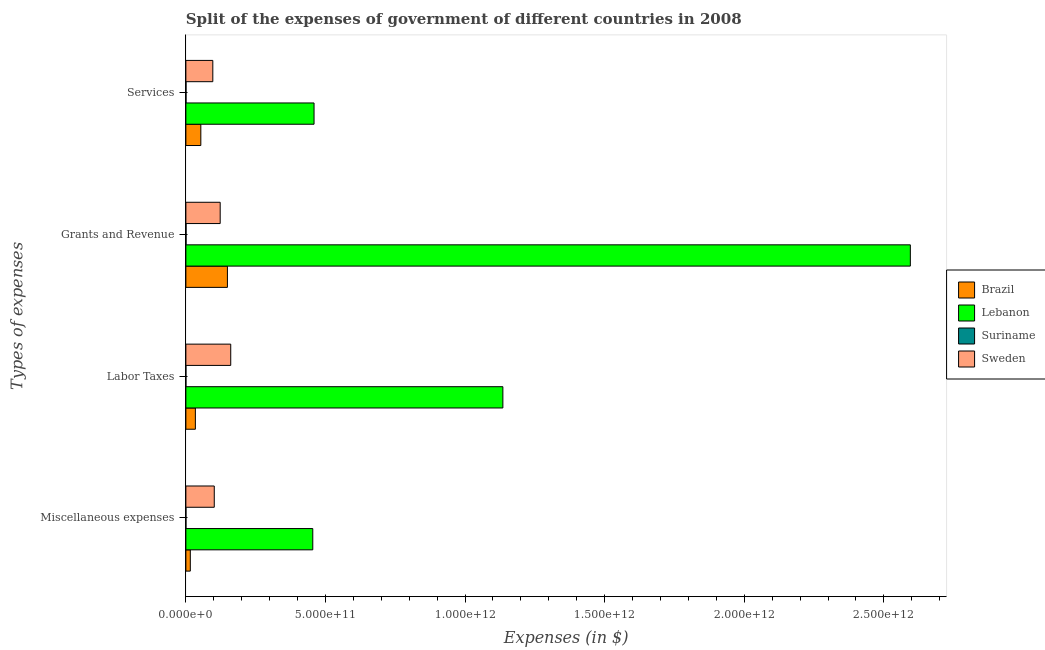What is the label of the 4th group of bars from the top?
Offer a very short reply. Miscellaneous expenses. What is the amount spent on miscellaneous expenses in Lebanon?
Your answer should be compact. 4.55e+11. Across all countries, what is the maximum amount spent on labor taxes?
Provide a short and direct response. 1.14e+12. Across all countries, what is the minimum amount spent on miscellaneous expenses?
Provide a short and direct response. 2.44e+08. In which country was the amount spent on services maximum?
Keep it short and to the point. Lebanon. In which country was the amount spent on miscellaneous expenses minimum?
Provide a short and direct response. Suriname. What is the total amount spent on miscellaneous expenses in the graph?
Offer a very short reply. 5.72e+11. What is the difference between the amount spent on grants and revenue in Suriname and that in Lebanon?
Keep it short and to the point. -2.59e+12. What is the difference between the amount spent on miscellaneous expenses in Brazil and the amount spent on labor taxes in Suriname?
Your response must be concise. 1.58e+1. What is the average amount spent on grants and revenue per country?
Provide a succinct answer. 7.17e+11. What is the difference between the amount spent on grants and revenue and amount spent on services in Lebanon?
Your response must be concise. 2.14e+12. In how many countries, is the amount spent on grants and revenue greater than 900000000000 $?
Offer a terse response. 1. What is the ratio of the amount spent on labor taxes in Sweden to that in Suriname?
Your response must be concise. 1904.67. Is the amount spent on labor taxes in Sweden less than that in Suriname?
Make the answer very short. No. What is the difference between the highest and the second highest amount spent on labor taxes?
Offer a very short reply. 9.75e+11. What is the difference between the highest and the lowest amount spent on services?
Your answer should be compact. 4.59e+11. Is the sum of the amount spent on labor taxes in Brazil and Suriname greater than the maximum amount spent on grants and revenue across all countries?
Give a very brief answer. No. Is it the case that in every country, the sum of the amount spent on miscellaneous expenses and amount spent on labor taxes is greater than the amount spent on grants and revenue?
Make the answer very short. No. How many bars are there?
Provide a short and direct response. 16. Are all the bars in the graph horizontal?
Ensure brevity in your answer.  Yes. How many countries are there in the graph?
Your answer should be very brief. 4. What is the difference between two consecutive major ticks on the X-axis?
Give a very brief answer. 5.00e+11. How many legend labels are there?
Your answer should be compact. 4. How are the legend labels stacked?
Ensure brevity in your answer.  Vertical. What is the title of the graph?
Give a very brief answer. Split of the expenses of government of different countries in 2008. What is the label or title of the X-axis?
Your answer should be compact. Expenses (in $). What is the label or title of the Y-axis?
Offer a very short reply. Types of expenses. What is the Expenses (in $) of Brazil in Miscellaneous expenses?
Give a very brief answer. 1.59e+1. What is the Expenses (in $) of Lebanon in Miscellaneous expenses?
Provide a short and direct response. 4.55e+11. What is the Expenses (in $) in Suriname in Miscellaneous expenses?
Your answer should be very brief. 2.44e+08. What is the Expenses (in $) in Sweden in Miscellaneous expenses?
Your answer should be compact. 1.02e+11. What is the Expenses (in $) in Brazil in Labor Taxes?
Provide a succinct answer. 3.40e+1. What is the Expenses (in $) of Lebanon in Labor Taxes?
Your answer should be compact. 1.14e+12. What is the Expenses (in $) of Suriname in Labor Taxes?
Offer a very short reply. 8.44e+07. What is the Expenses (in $) in Sweden in Labor Taxes?
Provide a succinct answer. 1.61e+11. What is the Expenses (in $) of Brazil in Grants and Revenue?
Ensure brevity in your answer.  1.49e+11. What is the Expenses (in $) in Lebanon in Grants and Revenue?
Offer a very short reply. 2.59e+12. What is the Expenses (in $) of Suriname in Grants and Revenue?
Give a very brief answer. 6.72e+08. What is the Expenses (in $) in Sweden in Grants and Revenue?
Your answer should be compact. 1.23e+11. What is the Expenses (in $) of Brazil in Services?
Your answer should be very brief. 5.36e+1. What is the Expenses (in $) of Lebanon in Services?
Provide a short and direct response. 4.59e+11. What is the Expenses (in $) in Suriname in Services?
Offer a terse response. 4.88e+08. What is the Expenses (in $) of Sweden in Services?
Provide a short and direct response. 9.65e+1. Across all Types of expenses, what is the maximum Expenses (in $) of Brazil?
Give a very brief answer. 1.49e+11. Across all Types of expenses, what is the maximum Expenses (in $) of Lebanon?
Ensure brevity in your answer.  2.59e+12. Across all Types of expenses, what is the maximum Expenses (in $) of Suriname?
Make the answer very short. 6.72e+08. Across all Types of expenses, what is the maximum Expenses (in $) in Sweden?
Ensure brevity in your answer.  1.61e+11. Across all Types of expenses, what is the minimum Expenses (in $) of Brazil?
Your answer should be compact. 1.59e+1. Across all Types of expenses, what is the minimum Expenses (in $) in Lebanon?
Ensure brevity in your answer.  4.55e+11. Across all Types of expenses, what is the minimum Expenses (in $) in Suriname?
Provide a short and direct response. 8.44e+07. Across all Types of expenses, what is the minimum Expenses (in $) of Sweden?
Make the answer very short. 9.65e+1. What is the total Expenses (in $) in Brazil in the graph?
Ensure brevity in your answer.  2.52e+11. What is the total Expenses (in $) in Lebanon in the graph?
Keep it short and to the point. 4.64e+12. What is the total Expenses (in $) of Suriname in the graph?
Make the answer very short. 1.49e+09. What is the total Expenses (in $) in Sweden in the graph?
Provide a succinct answer. 4.82e+11. What is the difference between the Expenses (in $) in Brazil in Miscellaneous expenses and that in Labor Taxes?
Your answer should be compact. -1.81e+1. What is the difference between the Expenses (in $) in Lebanon in Miscellaneous expenses and that in Labor Taxes?
Make the answer very short. -6.81e+11. What is the difference between the Expenses (in $) of Suriname in Miscellaneous expenses and that in Labor Taxes?
Provide a short and direct response. 1.59e+08. What is the difference between the Expenses (in $) in Sweden in Miscellaneous expenses and that in Labor Taxes?
Provide a short and direct response. -5.90e+1. What is the difference between the Expenses (in $) in Brazil in Miscellaneous expenses and that in Grants and Revenue?
Offer a very short reply. -1.33e+11. What is the difference between the Expenses (in $) of Lebanon in Miscellaneous expenses and that in Grants and Revenue?
Your answer should be compact. -2.14e+12. What is the difference between the Expenses (in $) in Suriname in Miscellaneous expenses and that in Grants and Revenue?
Provide a short and direct response. -4.29e+08. What is the difference between the Expenses (in $) of Sweden in Miscellaneous expenses and that in Grants and Revenue?
Your answer should be compact. -2.12e+1. What is the difference between the Expenses (in $) of Brazil in Miscellaneous expenses and that in Services?
Give a very brief answer. -3.77e+1. What is the difference between the Expenses (in $) of Lebanon in Miscellaneous expenses and that in Services?
Provide a short and direct response. -4.56e+09. What is the difference between the Expenses (in $) of Suriname in Miscellaneous expenses and that in Services?
Offer a very short reply. -2.44e+08. What is the difference between the Expenses (in $) in Sweden in Miscellaneous expenses and that in Services?
Offer a terse response. 5.22e+09. What is the difference between the Expenses (in $) in Brazil in Labor Taxes and that in Grants and Revenue?
Offer a terse response. -1.15e+11. What is the difference between the Expenses (in $) of Lebanon in Labor Taxes and that in Grants and Revenue?
Ensure brevity in your answer.  -1.46e+12. What is the difference between the Expenses (in $) of Suriname in Labor Taxes and that in Grants and Revenue?
Offer a terse response. -5.88e+08. What is the difference between the Expenses (in $) of Sweden in Labor Taxes and that in Grants and Revenue?
Your answer should be very brief. 3.78e+1. What is the difference between the Expenses (in $) in Brazil in Labor Taxes and that in Services?
Provide a short and direct response. -1.96e+1. What is the difference between the Expenses (in $) of Lebanon in Labor Taxes and that in Services?
Offer a terse response. 6.76e+11. What is the difference between the Expenses (in $) in Suriname in Labor Taxes and that in Services?
Provide a short and direct response. -4.04e+08. What is the difference between the Expenses (in $) in Sweden in Labor Taxes and that in Services?
Keep it short and to the point. 6.42e+1. What is the difference between the Expenses (in $) in Brazil in Grants and Revenue and that in Services?
Ensure brevity in your answer.  9.53e+1. What is the difference between the Expenses (in $) of Lebanon in Grants and Revenue and that in Services?
Make the answer very short. 2.14e+12. What is the difference between the Expenses (in $) in Suriname in Grants and Revenue and that in Services?
Ensure brevity in your answer.  1.84e+08. What is the difference between the Expenses (in $) in Sweden in Grants and Revenue and that in Services?
Provide a short and direct response. 2.64e+1. What is the difference between the Expenses (in $) of Brazil in Miscellaneous expenses and the Expenses (in $) of Lebanon in Labor Taxes?
Ensure brevity in your answer.  -1.12e+12. What is the difference between the Expenses (in $) in Brazil in Miscellaneous expenses and the Expenses (in $) in Suriname in Labor Taxes?
Provide a succinct answer. 1.58e+1. What is the difference between the Expenses (in $) in Brazil in Miscellaneous expenses and the Expenses (in $) in Sweden in Labor Taxes?
Keep it short and to the point. -1.45e+11. What is the difference between the Expenses (in $) in Lebanon in Miscellaneous expenses and the Expenses (in $) in Suriname in Labor Taxes?
Your response must be concise. 4.54e+11. What is the difference between the Expenses (in $) of Lebanon in Miscellaneous expenses and the Expenses (in $) of Sweden in Labor Taxes?
Provide a succinct answer. 2.94e+11. What is the difference between the Expenses (in $) of Suriname in Miscellaneous expenses and the Expenses (in $) of Sweden in Labor Taxes?
Make the answer very short. -1.60e+11. What is the difference between the Expenses (in $) of Brazil in Miscellaneous expenses and the Expenses (in $) of Lebanon in Grants and Revenue?
Provide a short and direct response. -2.58e+12. What is the difference between the Expenses (in $) in Brazil in Miscellaneous expenses and the Expenses (in $) in Suriname in Grants and Revenue?
Your answer should be compact. 1.52e+1. What is the difference between the Expenses (in $) in Brazil in Miscellaneous expenses and the Expenses (in $) in Sweden in Grants and Revenue?
Your answer should be compact. -1.07e+11. What is the difference between the Expenses (in $) of Lebanon in Miscellaneous expenses and the Expenses (in $) of Suriname in Grants and Revenue?
Offer a terse response. 4.54e+11. What is the difference between the Expenses (in $) in Lebanon in Miscellaneous expenses and the Expenses (in $) in Sweden in Grants and Revenue?
Offer a very short reply. 3.32e+11. What is the difference between the Expenses (in $) of Suriname in Miscellaneous expenses and the Expenses (in $) of Sweden in Grants and Revenue?
Keep it short and to the point. -1.23e+11. What is the difference between the Expenses (in $) of Brazil in Miscellaneous expenses and the Expenses (in $) of Lebanon in Services?
Your answer should be very brief. -4.43e+11. What is the difference between the Expenses (in $) of Brazil in Miscellaneous expenses and the Expenses (in $) of Suriname in Services?
Provide a succinct answer. 1.54e+1. What is the difference between the Expenses (in $) of Brazil in Miscellaneous expenses and the Expenses (in $) of Sweden in Services?
Provide a succinct answer. -8.05e+1. What is the difference between the Expenses (in $) in Lebanon in Miscellaneous expenses and the Expenses (in $) in Suriname in Services?
Offer a terse response. 4.54e+11. What is the difference between the Expenses (in $) in Lebanon in Miscellaneous expenses and the Expenses (in $) in Sweden in Services?
Make the answer very short. 3.58e+11. What is the difference between the Expenses (in $) of Suriname in Miscellaneous expenses and the Expenses (in $) of Sweden in Services?
Your answer should be very brief. -9.62e+1. What is the difference between the Expenses (in $) of Brazil in Labor Taxes and the Expenses (in $) of Lebanon in Grants and Revenue?
Make the answer very short. -2.56e+12. What is the difference between the Expenses (in $) in Brazil in Labor Taxes and the Expenses (in $) in Suriname in Grants and Revenue?
Ensure brevity in your answer.  3.33e+1. What is the difference between the Expenses (in $) of Brazil in Labor Taxes and the Expenses (in $) of Sweden in Grants and Revenue?
Your response must be concise. -8.89e+1. What is the difference between the Expenses (in $) in Lebanon in Labor Taxes and the Expenses (in $) in Suriname in Grants and Revenue?
Give a very brief answer. 1.13e+12. What is the difference between the Expenses (in $) in Lebanon in Labor Taxes and the Expenses (in $) in Sweden in Grants and Revenue?
Your answer should be compact. 1.01e+12. What is the difference between the Expenses (in $) of Suriname in Labor Taxes and the Expenses (in $) of Sweden in Grants and Revenue?
Give a very brief answer. -1.23e+11. What is the difference between the Expenses (in $) in Brazil in Labor Taxes and the Expenses (in $) in Lebanon in Services?
Make the answer very short. -4.25e+11. What is the difference between the Expenses (in $) in Brazil in Labor Taxes and the Expenses (in $) in Suriname in Services?
Ensure brevity in your answer.  3.35e+1. What is the difference between the Expenses (in $) of Brazil in Labor Taxes and the Expenses (in $) of Sweden in Services?
Your answer should be very brief. -6.24e+1. What is the difference between the Expenses (in $) in Lebanon in Labor Taxes and the Expenses (in $) in Suriname in Services?
Keep it short and to the point. 1.13e+12. What is the difference between the Expenses (in $) in Lebanon in Labor Taxes and the Expenses (in $) in Sweden in Services?
Offer a terse response. 1.04e+12. What is the difference between the Expenses (in $) in Suriname in Labor Taxes and the Expenses (in $) in Sweden in Services?
Offer a terse response. -9.64e+1. What is the difference between the Expenses (in $) in Brazil in Grants and Revenue and the Expenses (in $) in Lebanon in Services?
Provide a succinct answer. -3.10e+11. What is the difference between the Expenses (in $) in Brazil in Grants and Revenue and the Expenses (in $) in Suriname in Services?
Your answer should be compact. 1.48e+11. What is the difference between the Expenses (in $) in Brazil in Grants and Revenue and the Expenses (in $) in Sweden in Services?
Provide a succinct answer. 5.24e+1. What is the difference between the Expenses (in $) in Lebanon in Grants and Revenue and the Expenses (in $) in Suriname in Services?
Provide a short and direct response. 2.59e+12. What is the difference between the Expenses (in $) of Lebanon in Grants and Revenue and the Expenses (in $) of Sweden in Services?
Keep it short and to the point. 2.50e+12. What is the difference between the Expenses (in $) in Suriname in Grants and Revenue and the Expenses (in $) in Sweden in Services?
Your answer should be very brief. -9.58e+1. What is the average Expenses (in $) in Brazil per Types of expenses?
Offer a terse response. 6.31e+1. What is the average Expenses (in $) of Lebanon per Types of expenses?
Keep it short and to the point. 1.16e+12. What is the average Expenses (in $) in Suriname per Types of expenses?
Make the answer very short. 3.72e+08. What is the average Expenses (in $) in Sweden per Types of expenses?
Ensure brevity in your answer.  1.20e+11. What is the difference between the Expenses (in $) in Brazil and Expenses (in $) in Lebanon in Miscellaneous expenses?
Make the answer very short. -4.39e+11. What is the difference between the Expenses (in $) of Brazil and Expenses (in $) of Suriname in Miscellaneous expenses?
Offer a very short reply. 1.57e+1. What is the difference between the Expenses (in $) of Brazil and Expenses (in $) of Sweden in Miscellaneous expenses?
Provide a succinct answer. -8.58e+1. What is the difference between the Expenses (in $) in Lebanon and Expenses (in $) in Suriname in Miscellaneous expenses?
Offer a very short reply. 4.54e+11. What is the difference between the Expenses (in $) in Lebanon and Expenses (in $) in Sweden in Miscellaneous expenses?
Your answer should be compact. 3.53e+11. What is the difference between the Expenses (in $) of Suriname and Expenses (in $) of Sweden in Miscellaneous expenses?
Ensure brevity in your answer.  -1.01e+11. What is the difference between the Expenses (in $) in Brazil and Expenses (in $) in Lebanon in Labor Taxes?
Your answer should be compact. -1.10e+12. What is the difference between the Expenses (in $) in Brazil and Expenses (in $) in Suriname in Labor Taxes?
Your response must be concise. 3.39e+1. What is the difference between the Expenses (in $) of Brazil and Expenses (in $) of Sweden in Labor Taxes?
Offer a very short reply. -1.27e+11. What is the difference between the Expenses (in $) of Lebanon and Expenses (in $) of Suriname in Labor Taxes?
Offer a very short reply. 1.14e+12. What is the difference between the Expenses (in $) of Lebanon and Expenses (in $) of Sweden in Labor Taxes?
Your answer should be very brief. 9.75e+11. What is the difference between the Expenses (in $) of Suriname and Expenses (in $) of Sweden in Labor Taxes?
Make the answer very short. -1.61e+11. What is the difference between the Expenses (in $) in Brazil and Expenses (in $) in Lebanon in Grants and Revenue?
Offer a terse response. -2.45e+12. What is the difference between the Expenses (in $) of Brazil and Expenses (in $) of Suriname in Grants and Revenue?
Ensure brevity in your answer.  1.48e+11. What is the difference between the Expenses (in $) of Brazil and Expenses (in $) of Sweden in Grants and Revenue?
Keep it short and to the point. 2.60e+1. What is the difference between the Expenses (in $) of Lebanon and Expenses (in $) of Suriname in Grants and Revenue?
Make the answer very short. 2.59e+12. What is the difference between the Expenses (in $) in Lebanon and Expenses (in $) in Sweden in Grants and Revenue?
Offer a terse response. 2.47e+12. What is the difference between the Expenses (in $) of Suriname and Expenses (in $) of Sweden in Grants and Revenue?
Keep it short and to the point. -1.22e+11. What is the difference between the Expenses (in $) of Brazil and Expenses (in $) of Lebanon in Services?
Your answer should be very brief. -4.06e+11. What is the difference between the Expenses (in $) of Brazil and Expenses (in $) of Suriname in Services?
Give a very brief answer. 5.31e+1. What is the difference between the Expenses (in $) in Brazil and Expenses (in $) in Sweden in Services?
Provide a succinct answer. -4.29e+1. What is the difference between the Expenses (in $) in Lebanon and Expenses (in $) in Suriname in Services?
Ensure brevity in your answer.  4.59e+11. What is the difference between the Expenses (in $) in Lebanon and Expenses (in $) in Sweden in Services?
Make the answer very short. 3.63e+11. What is the difference between the Expenses (in $) in Suriname and Expenses (in $) in Sweden in Services?
Provide a succinct answer. -9.60e+1. What is the ratio of the Expenses (in $) of Brazil in Miscellaneous expenses to that in Labor Taxes?
Your answer should be compact. 0.47. What is the ratio of the Expenses (in $) in Lebanon in Miscellaneous expenses to that in Labor Taxes?
Keep it short and to the point. 0.4. What is the ratio of the Expenses (in $) in Suriname in Miscellaneous expenses to that in Labor Taxes?
Provide a short and direct response. 2.89. What is the ratio of the Expenses (in $) in Sweden in Miscellaneous expenses to that in Labor Taxes?
Offer a very short reply. 0.63. What is the ratio of the Expenses (in $) in Brazil in Miscellaneous expenses to that in Grants and Revenue?
Ensure brevity in your answer.  0.11. What is the ratio of the Expenses (in $) in Lebanon in Miscellaneous expenses to that in Grants and Revenue?
Provide a succinct answer. 0.18. What is the ratio of the Expenses (in $) of Suriname in Miscellaneous expenses to that in Grants and Revenue?
Provide a succinct answer. 0.36. What is the ratio of the Expenses (in $) of Sweden in Miscellaneous expenses to that in Grants and Revenue?
Offer a very short reply. 0.83. What is the ratio of the Expenses (in $) of Brazil in Miscellaneous expenses to that in Services?
Provide a succinct answer. 0.3. What is the ratio of the Expenses (in $) of Lebanon in Miscellaneous expenses to that in Services?
Provide a succinct answer. 0.99. What is the ratio of the Expenses (in $) in Suriname in Miscellaneous expenses to that in Services?
Provide a short and direct response. 0.5. What is the ratio of the Expenses (in $) in Sweden in Miscellaneous expenses to that in Services?
Keep it short and to the point. 1.05. What is the ratio of the Expenses (in $) of Brazil in Labor Taxes to that in Grants and Revenue?
Keep it short and to the point. 0.23. What is the ratio of the Expenses (in $) of Lebanon in Labor Taxes to that in Grants and Revenue?
Offer a very short reply. 0.44. What is the ratio of the Expenses (in $) of Suriname in Labor Taxes to that in Grants and Revenue?
Make the answer very short. 0.13. What is the ratio of the Expenses (in $) of Sweden in Labor Taxes to that in Grants and Revenue?
Provide a short and direct response. 1.31. What is the ratio of the Expenses (in $) in Brazil in Labor Taxes to that in Services?
Give a very brief answer. 0.64. What is the ratio of the Expenses (in $) in Lebanon in Labor Taxes to that in Services?
Keep it short and to the point. 2.47. What is the ratio of the Expenses (in $) of Suriname in Labor Taxes to that in Services?
Ensure brevity in your answer.  0.17. What is the ratio of the Expenses (in $) of Sweden in Labor Taxes to that in Services?
Ensure brevity in your answer.  1.67. What is the ratio of the Expenses (in $) in Brazil in Grants and Revenue to that in Services?
Ensure brevity in your answer.  2.78. What is the ratio of the Expenses (in $) of Lebanon in Grants and Revenue to that in Services?
Offer a very short reply. 5.65. What is the ratio of the Expenses (in $) in Suriname in Grants and Revenue to that in Services?
Ensure brevity in your answer.  1.38. What is the ratio of the Expenses (in $) of Sweden in Grants and Revenue to that in Services?
Your response must be concise. 1.27. What is the difference between the highest and the second highest Expenses (in $) in Brazil?
Provide a succinct answer. 9.53e+1. What is the difference between the highest and the second highest Expenses (in $) of Lebanon?
Keep it short and to the point. 1.46e+12. What is the difference between the highest and the second highest Expenses (in $) of Suriname?
Provide a short and direct response. 1.84e+08. What is the difference between the highest and the second highest Expenses (in $) in Sweden?
Give a very brief answer. 3.78e+1. What is the difference between the highest and the lowest Expenses (in $) in Brazil?
Ensure brevity in your answer.  1.33e+11. What is the difference between the highest and the lowest Expenses (in $) in Lebanon?
Your response must be concise. 2.14e+12. What is the difference between the highest and the lowest Expenses (in $) in Suriname?
Provide a succinct answer. 5.88e+08. What is the difference between the highest and the lowest Expenses (in $) in Sweden?
Ensure brevity in your answer.  6.42e+1. 